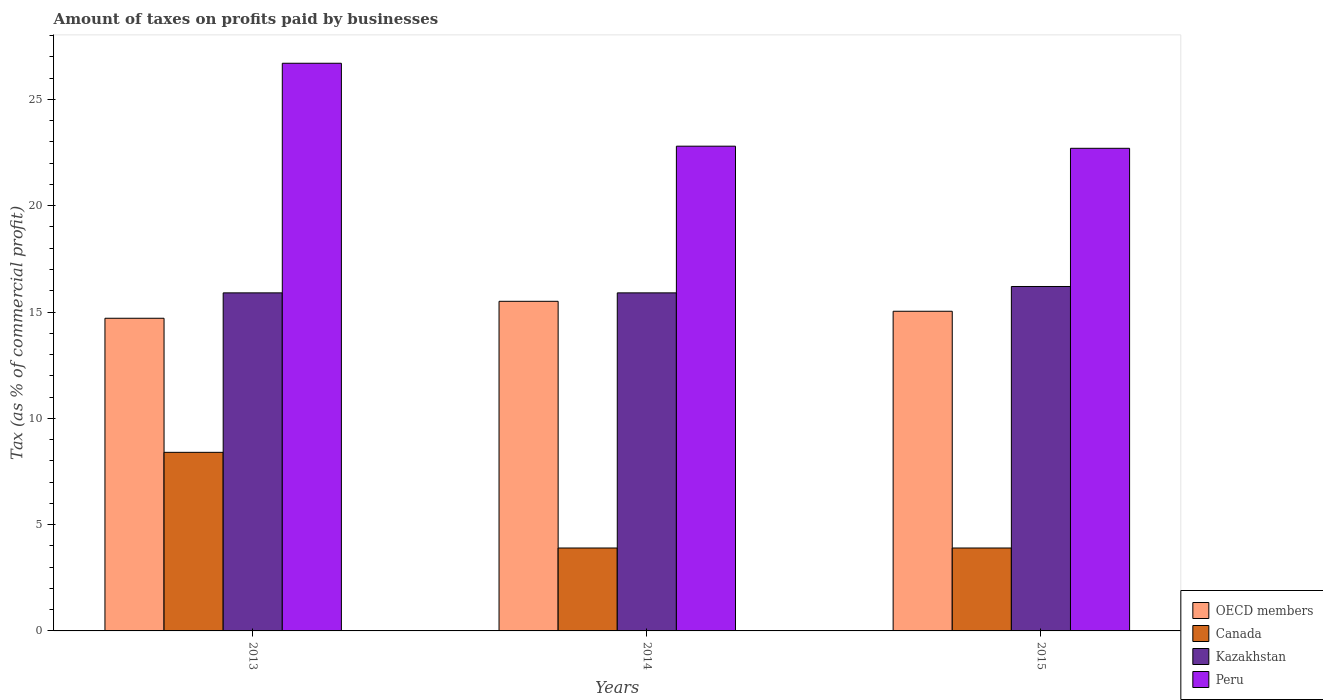How many different coloured bars are there?
Offer a terse response. 4. How many bars are there on the 3rd tick from the right?
Your response must be concise. 4. What is the label of the 3rd group of bars from the left?
Your response must be concise. 2015. What is the percentage of taxes paid by businesses in Peru in 2013?
Offer a very short reply. 26.7. Across all years, what is the maximum percentage of taxes paid by businesses in Canada?
Ensure brevity in your answer.  8.4. Across all years, what is the minimum percentage of taxes paid by businesses in Peru?
Provide a short and direct response. 22.7. In which year was the percentage of taxes paid by businesses in Peru maximum?
Provide a succinct answer. 2013. In which year was the percentage of taxes paid by businesses in Canada minimum?
Offer a terse response. 2014. What is the total percentage of taxes paid by businesses in OECD members in the graph?
Make the answer very short. 45.25. What is the difference between the percentage of taxes paid by businesses in Peru in 2013 and that in 2015?
Give a very brief answer. 4. What is the difference between the percentage of taxes paid by businesses in Kazakhstan in 2014 and the percentage of taxes paid by businesses in OECD members in 2013?
Ensure brevity in your answer.  1.19. What is the average percentage of taxes paid by businesses in Peru per year?
Ensure brevity in your answer.  24.07. In the year 2014, what is the difference between the percentage of taxes paid by businesses in Peru and percentage of taxes paid by businesses in OECD members?
Give a very brief answer. 7.3. What is the ratio of the percentage of taxes paid by businesses in OECD members in 2013 to that in 2014?
Offer a terse response. 0.95. Is the percentage of taxes paid by businesses in Kazakhstan in 2013 less than that in 2015?
Offer a terse response. Yes. Is the difference between the percentage of taxes paid by businesses in Peru in 2014 and 2015 greater than the difference between the percentage of taxes paid by businesses in OECD members in 2014 and 2015?
Give a very brief answer. No. What is the difference between the highest and the lowest percentage of taxes paid by businesses in OECD members?
Offer a terse response. 0.8. What does the 4th bar from the left in 2013 represents?
Give a very brief answer. Peru. What is the difference between two consecutive major ticks on the Y-axis?
Offer a terse response. 5. Are the values on the major ticks of Y-axis written in scientific E-notation?
Your answer should be compact. No. Does the graph contain any zero values?
Make the answer very short. No. Does the graph contain grids?
Make the answer very short. No. Where does the legend appear in the graph?
Keep it short and to the point. Bottom right. How are the legend labels stacked?
Provide a succinct answer. Vertical. What is the title of the graph?
Provide a succinct answer. Amount of taxes on profits paid by businesses. What is the label or title of the Y-axis?
Your answer should be compact. Tax (as % of commercial profit). What is the Tax (as % of commercial profit) of OECD members in 2013?
Give a very brief answer. 14.71. What is the Tax (as % of commercial profit) in Canada in 2013?
Offer a very short reply. 8.4. What is the Tax (as % of commercial profit) of Peru in 2013?
Offer a terse response. 26.7. What is the Tax (as % of commercial profit) in OECD members in 2014?
Keep it short and to the point. 15.5. What is the Tax (as % of commercial profit) of Kazakhstan in 2014?
Provide a succinct answer. 15.9. What is the Tax (as % of commercial profit) of Peru in 2014?
Provide a succinct answer. 22.8. What is the Tax (as % of commercial profit) of OECD members in 2015?
Provide a short and direct response. 15.04. What is the Tax (as % of commercial profit) of Kazakhstan in 2015?
Your response must be concise. 16.2. What is the Tax (as % of commercial profit) in Peru in 2015?
Offer a terse response. 22.7. Across all years, what is the maximum Tax (as % of commercial profit) in OECD members?
Give a very brief answer. 15.5. Across all years, what is the maximum Tax (as % of commercial profit) of Canada?
Offer a terse response. 8.4. Across all years, what is the maximum Tax (as % of commercial profit) of Kazakhstan?
Your response must be concise. 16.2. Across all years, what is the maximum Tax (as % of commercial profit) of Peru?
Keep it short and to the point. 26.7. Across all years, what is the minimum Tax (as % of commercial profit) in OECD members?
Your answer should be compact. 14.71. Across all years, what is the minimum Tax (as % of commercial profit) in Kazakhstan?
Your answer should be very brief. 15.9. Across all years, what is the minimum Tax (as % of commercial profit) of Peru?
Offer a terse response. 22.7. What is the total Tax (as % of commercial profit) of OECD members in the graph?
Your answer should be very brief. 45.25. What is the total Tax (as % of commercial profit) of Peru in the graph?
Make the answer very short. 72.2. What is the difference between the Tax (as % of commercial profit) of OECD members in 2013 and that in 2014?
Offer a very short reply. -0.8. What is the difference between the Tax (as % of commercial profit) of Kazakhstan in 2013 and that in 2014?
Your response must be concise. 0. What is the difference between the Tax (as % of commercial profit) in OECD members in 2013 and that in 2015?
Your answer should be very brief. -0.33. What is the difference between the Tax (as % of commercial profit) of Canada in 2013 and that in 2015?
Give a very brief answer. 4.5. What is the difference between the Tax (as % of commercial profit) of Kazakhstan in 2013 and that in 2015?
Keep it short and to the point. -0.3. What is the difference between the Tax (as % of commercial profit) of Peru in 2013 and that in 2015?
Provide a succinct answer. 4. What is the difference between the Tax (as % of commercial profit) in OECD members in 2014 and that in 2015?
Provide a short and direct response. 0.47. What is the difference between the Tax (as % of commercial profit) of OECD members in 2013 and the Tax (as % of commercial profit) of Canada in 2014?
Give a very brief answer. 10.81. What is the difference between the Tax (as % of commercial profit) of OECD members in 2013 and the Tax (as % of commercial profit) of Kazakhstan in 2014?
Provide a succinct answer. -1.19. What is the difference between the Tax (as % of commercial profit) in OECD members in 2013 and the Tax (as % of commercial profit) in Peru in 2014?
Your answer should be compact. -8.09. What is the difference between the Tax (as % of commercial profit) of Canada in 2013 and the Tax (as % of commercial profit) of Kazakhstan in 2014?
Provide a short and direct response. -7.5. What is the difference between the Tax (as % of commercial profit) of Canada in 2013 and the Tax (as % of commercial profit) of Peru in 2014?
Your response must be concise. -14.4. What is the difference between the Tax (as % of commercial profit) of OECD members in 2013 and the Tax (as % of commercial profit) of Canada in 2015?
Provide a short and direct response. 10.81. What is the difference between the Tax (as % of commercial profit) of OECD members in 2013 and the Tax (as % of commercial profit) of Kazakhstan in 2015?
Your answer should be very brief. -1.49. What is the difference between the Tax (as % of commercial profit) of OECD members in 2013 and the Tax (as % of commercial profit) of Peru in 2015?
Keep it short and to the point. -7.99. What is the difference between the Tax (as % of commercial profit) of Canada in 2013 and the Tax (as % of commercial profit) of Kazakhstan in 2015?
Give a very brief answer. -7.8. What is the difference between the Tax (as % of commercial profit) of Canada in 2013 and the Tax (as % of commercial profit) of Peru in 2015?
Your response must be concise. -14.3. What is the difference between the Tax (as % of commercial profit) of Kazakhstan in 2013 and the Tax (as % of commercial profit) of Peru in 2015?
Ensure brevity in your answer.  -6.8. What is the difference between the Tax (as % of commercial profit) of OECD members in 2014 and the Tax (as % of commercial profit) of Canada in 2015?
Offer a terse response. 11.6. What is the difference between the Tax (as % of commercial profit) of OECD members in 2014 and the Tax (as % of commercial profit) of Kazakhstan in 2015?
Ensure brevity in your answer.  -0.7. What is the difference between the Tax (as % of commercial profit) of OECD members in 2014 and the Tax (as % of commercial profit) of Peru in 2015?
Keep it short and to the point. -7.2. What is the difference between the Tax (as % of commercial profit) of Canada in 2014 and the Tax (as % of commercial profit) of Peru in 2015?
Your response must be concise. -18.8. What is the average Tax (as % of commercial profit) in OECD members per year?
Provide a succinct answer. 15.08. What is the average Tax (as % of commercial profit) of Canada per year?
Ensure brevity in your answer.  5.4. What is the average Tax (as % of commercial profit) in Peru per year?
Your answer should be compact. 24.07. In the year 2013, what is the difference between the Tax (as % of commercial profit) of OECD members and Tax (as % of commercial profit) of Canada?
Offer a terse response. 6.31. In the year 2013, what is the difference between the Tax (as % of commercial profit) of OECD members and Tax (as % of commercial profit) of Kazakhstan?
Offer a very short reply. -1.19. In the year 2013, what is the difference between the Tax (as % of commercial profit) of OECD members and Tax (as % of commercial profit) of Peru?
Make the answer very short. -11.99. In the year 2013, what is the difference between the Tax (as % of commercial profit) of Canada and Tax (as % of commercial profit) of Peru?
Give a very brief answer. -18.3. In the year 2014, what is the difference between the Tax (as % of commercial profit) of OECD members and Tax (as % of commercial profit) of Canada?
Offer a terse response. 11.6. In the year 2014, what is the difference between the Tax (as % of commercial profit) of OECD members and Tax (as % of commercial profit) of Kazakhstan?
Your answer should be very brief. -0.4. In the year 2014, what is the difference between the Tax (as % of commercial profit) of OECD members and Tax (as % of commercial profit) of Peru?
Provide a succinct answer. -7.3. In the year 2014, what is the difference between the Tax (as % of commercial profit) of Canada and Tax (as % of commercial profit) of Kazakhstan?
Make the answer very short. -12. In the year 2014, what is the difference between the Tax (as % of commercial profit) of Canada and Tax (as % of commercial profit) of Peru?
Offer a very short reply. -18.9. In the year 2015, what is the difference between the Tax (as % of commercial profit) in OECD members and Tax (as % of commercial profit) in Canada?
Offer a very short reply. 11.14. In the year 2015, what is the difference between the Tax (as % of commercial profit) of OECD members and Tax (as % of commercial profit) of Kazakhstan?
Offer a very short reply. -1.16. In the year 2015, what is the difference between the Tax (as % of commercial profit) of OECD members and Tax (as % of commercial profit) of Peru?
Your answer should be very brief. -7.66. In the year 2015, what is the difference between the Tax (as % of commercial profit) in Canada and Tax (as % of commercial profit) in Kazakhstan?
Provide a short and direct response. -12.3. In the year 2015, what is the difference between the Tax (as % of commercial profit) in Canada and Tax (as % of commercial profit) in Peru?
Keep it short and to the point. -18.8. What is the ratio of the Tax (as % of commercial profit) in OECD members in 2013 to that in 2014?
Offer a very short reply. 0.95. What is the ratio of the Tax (as % of commercial profit) in Canada in 2013 to that in 2014?
Ensure brevity in your answer.  2.15. What is the ratio of the Tax (as % of commercial profit) of Kazakhstan in 2013 to that in 2014?
Ensure brevity in your answer.  1. What is the ratio of the Tax (as % of commercial profit) of Peru in 2013 to that in 2014?
Make the answer very short. 1.17. What is the ratio of the Tax (as % of commercial profit) in OECD members in 2013 to that in 2015?
Give a very brief answer. 0.98. What is the ratio of the Tax (as % of commercial profit) of Canada in 2013 to that in 2015?
Your response must be concise. 2.15. What is the ratio of the Tax (as % of commercial profit) in Kazakhstan in 2013 to that in 2015?
Ensure brevity in your answer.  0.98. What is the ratio of the Tax (as % of commercial profit) of Peru in 2013 to that in 2015?
Offer a very short reply. 1.18. What is the ratio of the Tax (as % of commercial profit) of OECD members in 2014 to that in 2015?
Keep it short and to the point. 1.03. What is the ratio of the Tax (as % of commercial profit) of Canada in 2014 to that in 2015?
Your answer should be very brief. 1. What is the ratio of the Tax (as % of commercial profit) in Kazakhstan in 2014 to that in 2015?
Keep it short and to the point. 0.98. What is the ratio of the Tax (as % of commercial profit) of Peru in 2014 to that in 2015?
Offer a terse response. 1. What is the difference between the highest and the second highest Tax (as % of commercial profit) of OECD members?
Make the answer very short. 0.47. What is the difference between the highest and the second highest Tax (as % of commercial profit) in Peru?
Your answer should be compact. 3.9. What is the difference between the highest and the lowest Tax (as % of commercial profit) of OECD members?
Keep it short and to the point. 0.8. What is the difference between the highest and the lowest Tax (as % of commercial profit) of Kazakhstan?
Your answer should be very brief. 0.3. 